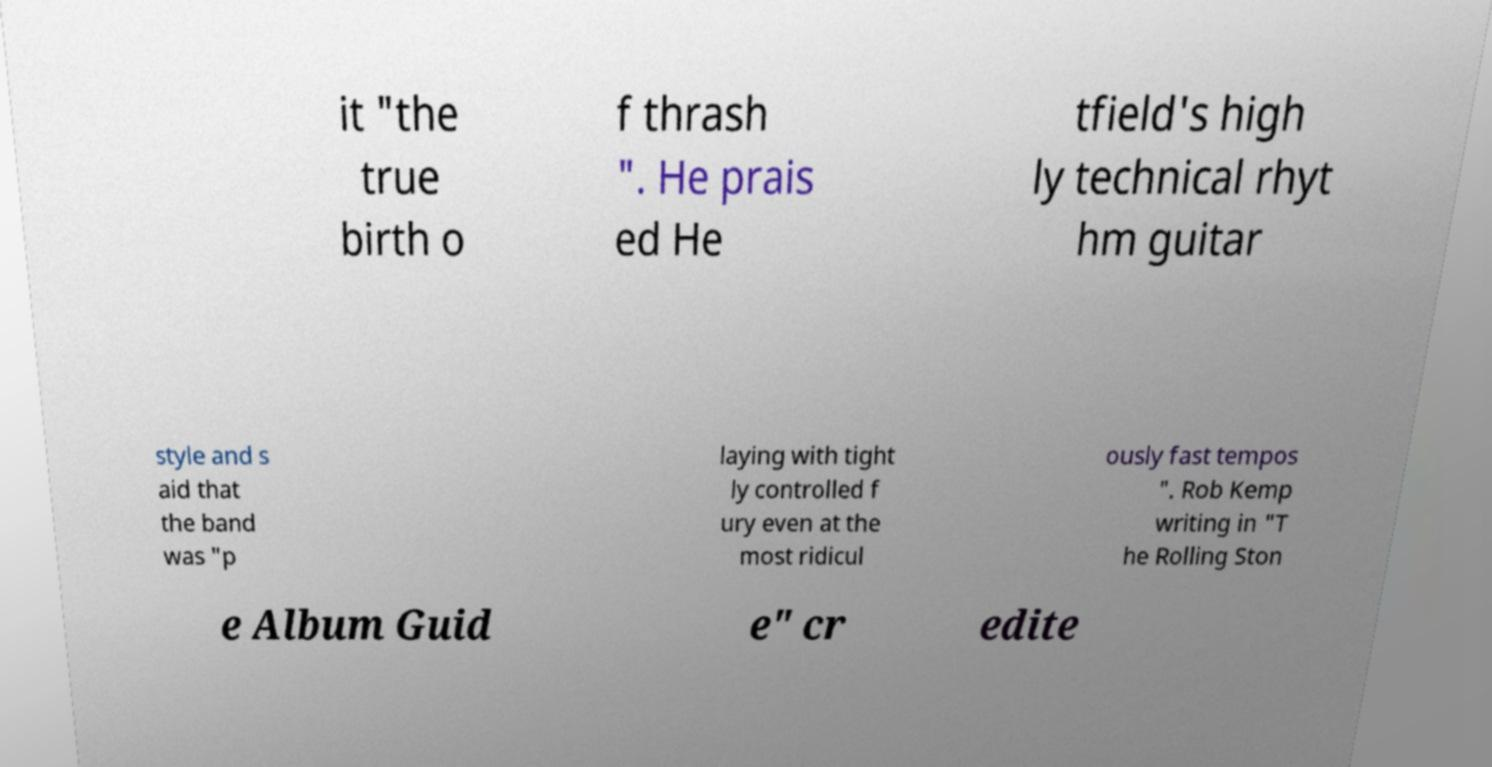There's text embedded in this image that I need extracted. Can you transcribe it verbatim? it "the true birth o f thrash ". He prais ed He tfield's high ly technical rhyt hm guitar style and s aid that the band was "p laying with tight ly controlled f ury even at the most ridicul ously fast tempos ". Rob Kemp writing in "T he Rolling Ston e Album Guid e" cr edite 